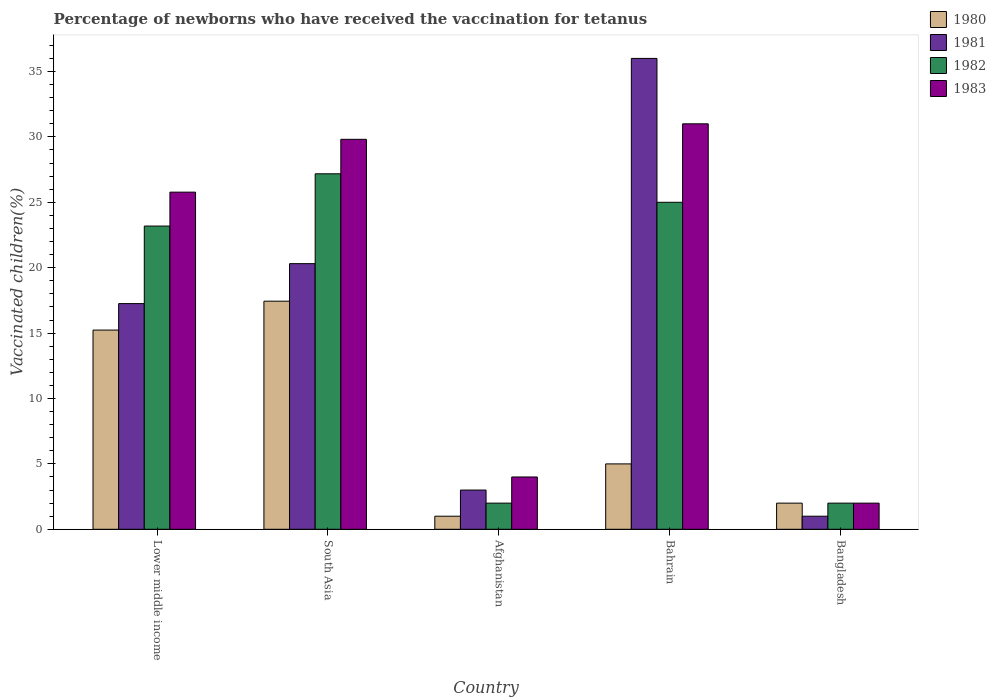Are the number of bars per tick equal to the number of legend labels?
Your answer should be very brief. Yes. What is the label of the 1st group of bars from the left?
Your answer should be very brief. Lower middle income. In how many cases, is the number of bars for a given country not equal to the number of legend labels?
Provide a short and direct response. 0. What is the percentage of vaccinated children in 1982 in Bangladesh?
Your answer should be compact. 2. Across all countries, what is the minimum percentage of vaccinated children in 1981?
Provide a succinct answer. 1. In which country was the percentage of vaccinated children in 1982 maximum?
Give a very brief answer. South Asia. What is the total percentage of vaccinated children in 1981 in the graph?
Offer a terse response. 77.56. What is the difference between the percentage of vaccinated children in 1982 in South Asia and the percentage of vaccinated children in 1981 in Bangladesh?
Your answer should be very brief. 26.18. What is the average percentage of vaccinated children in 1981 per country?
Offer a very short reply. 15.51. What is the difference between the percentage of vaccinated children of/in 1982 and percentage of vaccinated children of/in 1983 in Lower middle income?
Give a very brief answer. -2.59. In how many countries, is the percentage of vaccinated children in 1982 greater than 23 %?
Give a very brief answer. 3. What is the ratio of the percentage of vaccinated children in 1983 in Afghanistan to that in South Asia?
Provide a short and direct response. 0.13. Is the difference between the percentage of vaccinated children in 1982 in Bahrain and South Asia greater than the difference between the percentage of vaccinated children in 1983 in Bahrain and South Asia?
Ensure brevity in your answer.  No. What is the difference between the highest and the second highest percentage of vaccinated children in 1982?
Your response must be concise. -2.18. What is the difference between the highest and the lowest percentage of vaccinated children in 1980?
Keep it short and to the point. 16.44. In how many countries, is the percentage of vaccinated children in 1983 greater than the average percentage of vaccinated children in 1983 taken over all countries?
Provide a succinct answer. 3. How many bars are there?
Your response must be concise. 20. Are all the bars in the graph horizontal?
Make the answer very short. No. How many countries are there in the graph?
Offer a terse response. 5. What is the difference between two consecutive major ticks on the Y-axis?
Your answer should be very brief. 5. Does the graph contain grids?
Offer a terse response. No. How many legend labels are there?
Offer a very short reply. 4. How are the legend labels stacked?
Your answer should be very brief. Vertical. What is the title of the graph?
Your answer should be very brief. Percentage of newborns who have received the vaccination for tetanus. What is the label or title of the X-axis?
Offer a very short reply. Country. What is the label or title of the Y-axis?
Provide a short and direct response. Vaccinated children(%). What is the Vaccinated children(%) of 1980 in Lower middle income?
Provide a short and direct response. 15.23. What is the Vaccinated children(%) of 1981 in Lower middle income?
Offer a very short reply. 17.25. What is the Vaccinated children(%) of 1982 in Lower middle income?
Your response must be concise. 23.18. What is the Vaccinated children(%) in 1983 in Lower middle income?
Make the answer very short. 25.78. What is the Vaccinated children(%) in 1980 in South Asia?
Provide a succinct answer. 17.44. What is the Vaccinated children(%) of 1981 in South Asia?
Make the answer very short. 20.31. What is the Vaccinated children(%) in 1982 in South Asia?
Give a very brief answer. 27.18. What is the Vaccinated children(%) in 1983 in South Asia?
Offer a terse response. 29.81. What is the Vaccinated children(%) of 1980 in Afghanistan?
Make the answer very short. 1. What is the Vaccinated children(%) in 1982 in Afghanistan?
Your answer should be very brief. 2. What is the Vaccinated children(%) in 1982 in Bahrain?
Your answer should be compact. 25. What is the Vaccinated children(%) of 1983 in Bahrain?
Make the answer very short. 31. What is the Vaccinated children(%) in 1981 in Bangladesh?
Offer a very short reply. 1. What is the Vaccinated children(%) of 1982 in Bangladesh?
Offer a terse response. 2. Across all countries, what is the maximum Vaccinated children(%) of 1980?
Give a very brief answer. 17.44. Across all countries, what is the maximum Vaccinated children(%) of 1981?
Keep it short and to the point. 36. Across all countries, what is the maximum Vaccinated children(%) of 1982?
Your answer should be compact. 27.18. Across all countries, what is the maximum Vaccinated children(%) in 1983?
Make the answer very short. 31. Across all countries, what is the minimum Vaccinated children(%) of 1981?
Offer a terse response. 1. Across all countries, what is the minimum Vaccinated children(%) of 1983?
Your response must be concise. 2. What is the total Vaccinated children(%) of 1980 in the graph?
Keep it short and to the point. 40.67. What is the total Vaccinated children(%) in 1981 in the graph?
Offer a very short reply. 77.56. What is the total Vaccinated children(%) in 1982 in the graph?
Give a very brief answer. 79.36. What is the total Vaccinated children(%) in 1983 in the graph?
Give a very brief answer. 92.59. What is the difference between the Vaccinated children(%) in 1980 in Lower middle income and that in South Asia?
Offer a very short reply. -2.21. What is the difference between the Vaccinated children(%) in 1981 in Lower middle income and that in South Asia?
Your response must be concise. -3.05. What is the difference between the Vaccinated children(%) of 1982 in Lower middle income and that in South Asia?
Offer a terse response. -3.99. What is the difference between the Vaccinated children(%) of 1983 in Lower middle income and that in South Asia?
Ensure brevity in your answer.  -4.04. What is the difference between the Vaccinated children(%) in 1980 in Lower middle income and that in Afghanistan?
Make the answer very short. 14.23. What is the difference between the Vaccinated children(%) of 1981 in Lower middle income and that in Afghanistan?
Give a very brief answer. 14.25. What is the difference between the Vaccinated children(%) of 1982 in Lower middle income and that in Afghanistan?
Offer a terse response. 21.18. What is the difference between the Vaccinated children(%) of 1983 in Lower middle income and that in Afghanistan?
Keep it short and to the point. 21.78. What is the difference between the Vaccinated children(%) in 1980 in Lower middle income and that in Bahrain?
Your answer should be very brief. 10.23. What is the difference between the Vaccinated children(%) of 1981 in Lower middle income and that in Bahrain?
Offer a terse response. -18.75. What is the difference between the Vaccinated children(%) of 1982 in Lower middle income and that in Bahrain?
Ensure brevity in your answer.  -1.82. What is the difference between the Vaccinated children(%) of 1983 in Lower middle income and that in Bahrain?
Your answer should be compact. -5.22. What is the difference between the Vaccinated children(%) in 1980 in Lower middle income and that in Bangladesh?
Ensure brevity in your answer.  13.23. What is the difference between the Vaccinated children(%) in 1981 in Lower middle income and that in Bangladesh?
Your response must be concise. 16.25. What is the difference between the Vaccinated children(%) in 1982 in Lower middle income and that in Bangladesh?
Provide a short and direct response. 21.18. What is the difference between the Vaccinated children(%) of 1983 in Lower middle income and that in Bangladesh?
Give a very brief answer. 23.78. What is the difference between the Vaccinated children(%) of 1980 in South Asia and that in Afghanistan?
Keep it short and to the point. 16.44. What is the difference between the Vaccinated children(%) of 1981 in South Asia and that in Afghanistan?
Offer a terse response. 17.31. What is the difference between the Vaccinated children(%) of 1982 in South Asia and that in Afghanistan?
Your response must be concise. 25.18. What is the difference between the Vaccinated children(%) in 1983 in South Asia and that in Afghanistan?
Your answer should be very brief. 25.81. What is the difference between the Vaccinated children(%) in 1980 in South Asia and that in Bahrain?
Your answer should be compact. 12.44. What is the difference between the Vaccinated children(%) in 1981 in South Asia and that in Bahrain?
Provide a succinct answer. -15.69. What is the difference between the Vaccinated children(%) of 1982 in South Asia and that in Bahrain?
Give a very brief answer. 2.18. What is the difference between the Vaccinated children(%) of 1983 in South Asia and that in Bahrain?
Make the answer very short. -1.19. What is the difference between the Vaccinated children(%) in 1980 in South Asia and that in Bangladesh?
Ensure brevity in your answer.  15.44. What is the difference between the Vaccinated children(%) in 1981 in South Asia and that in Bangladesh?
Provide a succinct answer. 19.31. What is the difference between the Vaccinated children(%) in 1982 in South Asia and that in Bangladesh?
Give a very brief answer. 25.18. What is the difference between the Vaccinated children(%) of 1983 in South Asia and that in Bangladesh?
Your response must be concise. 27.81. What is the difference between the Vaccinated children(%) of 1981 in Afghanistan and that in Bahrain?
Give a very brief answer. -33. What is the difference between the Vaccinated children(%) in 1982 in Afghanistan and that in Bahrain?
Give a very brief answer. -23. What is the difference between the Vaccinated children(%) of 1983 in Afghanistan and that in Bahrain?
Give a very brief answer. -27. What is the difference between the Vaccinated children(%) of 1981 in Afghanistan and that in Bangladesh?
Provide a short and direct response. 2. What is the difference between the Vaccinated children(%) of 1983 in Afghanistan and that in Bangladesh?
Your answer should be compact. 2. What is the difference between the Vaccinated children(%) of 1980 in Bahrain and that in Bangladesh?
Offer a terse response. 3. What is the difference between the Vaccinated children(%) in 1983 in Bahrain and that in Bangladesh?
Give a very brief answer. 29. What is the difference between the Vaccinated children(%) in 1980 in Lower middle income and the Vaccinated children(%) in 1981 in South Asia?
Give a very brief answer. -5.08. What is the difference between the Vaccinated children(%) of 1980 in Lower middle income and the Vaccinated children(%) of 1982 in South Asia?
Offer a very short reply. -11.95. What is the difference between the Vaccinated children(%) in 1980 in Lower middle income and the Vaccinated children(%) in 1983 in South Asia?
Provide a succinct answer. -14.58. What is the difference between the Vaccinated children(%) in 1981 in Lower middle income and the Vaccinated children(%) in 1982 in South Asia?
Offer a terse response. -9.92. What is the difference between the Vaccinated children(%) of 1981 in Lower middle income and the Vaccinated children(%) of 1983 in South Asia?
Give a very brief answer. -12.56. What is the difference between the Vaccinated children(%) of 1982 in Lower middle income and the Vaccinated children(%) of 1983 in South Asia?
Provide a short and direct response. -6.63. What is the difference between the Vaccinated children(%) in 1980 in Lower middle income and the Vaccinated children(%) in 1981 in Afghanistan?
Provide a succinct answer. 12.23. What is the difference between the Vaccinated children(%) of 1980 in Lower middle income and the Vaccinated children(%) of 1982 in Afghanistan?
Your answer should be very brief. 13.23. What is the difference between the Vaccinated children(%) in 1980 in Lower middle income and the Vaccinated children(%) in 1983 in Afghanistan?
Keep it short and to the point. 11.23. What is the difference between the Vaccinated children(%) of 1981 in Lower middle income and the Vaccinated children(%) of 1982 in Afghanistan?
Your response must be concise. 15.25. What is the difference between the Vaccinated children(%) in 1981 in Lower middle income and the Vaccinated children(%) in 1983 in Afghanistan?
Keep it short and to the point. 13.25. What is the difference between the Vaccinated children(%) in 1982 in Lower middle income and the Vaccinated children(%) in 1983 in Afghanistan?
Keep it short and to the point. 19.18. What is the difference between the Vaccinated children(%) in 1980 in Lower middle income and the Vaccinated children(%) in 1981 in Bahrain?
Your answer should be very brief. -20.77. What is the difference between the Vaccinated children(%) in 1980 in Lower middle income and the Vaccinated children(%) in 1982 in Bahrain?
Offer a very short reply. -9.77. What is the difference between the Vaccinated children(%) of 1980 in Lower middle income and the Vaccinated children(%) of 1983 in Bahrain?
Ensure brevity in your answer.  -15.77. What is the difference between the Vaccinated children(%) of 1981 in Lower middle income and the Vaccinated children(%) of 1982 in Bahrain?
Your response must be concise. -7.75. What is the difference between the Vaccinated children(%) of 1981 in Lower middle income and the Vaccinated children(%) of 1983 in Bahrain?
Provide a short and direct response. -13.75. What is the difference between the Vaccinated children(%) of 1982 in Lower middle income and the Vaccinated children(%) of 1983 in Bahrain?
Provide a short and direct response. -7.82. What is the difference between the Vaccinated children(%) in 1980 in Lower middle income and the Vaccinated children(%) in 1981 in Bangladesh?
Your answer should be very brief. 14.23. What is the difference between the Vaccinated children(%) in 1980 in Lower middle income and the Vaccinated children(%) in 1982 in Bangladesh?
Offer a very short reply. 13.23. What is the difference between the Vaccinated children(%) of 1980 in Lower middle income and the Vaccinated children(%) of 1983 in Bangladesh?
Your answer should be very brief. 13.23. What is the difference between the Vaccinated children(%) in 1981 in Lower middle income and the Vaccinated children(%) in 1982 in Bangladesh?
Provide a short and direct response. 15.25. What is the difference between the Vaccinated children(%) of 1981 in Lower middle income and the Vaccinated children(%) of 1983 in Bangladesh?
Your answer should be compact. 15.25. What is the difference between the Vaccinated children(%) of 1982 in Lower middle income and the Vaccinated children(%) of 1983 in Bangladesh?
Your answer should be compact. 21.18. What is the difference between the Vaccinated children(%) in 1980 in South Asia and the Vaccinated children(%) in 1981 in Afghanistan?
Keep it short and to the point. 14.44. What is the difference between the Vaccinated children(%) of 1980 in South Asia and the Vaccinated children(%) of 1982 in Afghanistan?
Offer a terse response. 15.44. What is the difference between the Vaccinated children(%) of 1980 in South Asia and the Vaccinated children(%) of 1983 in Afghanistan?
Give a very brief answer. 13.44. What is the difference between the Vaccinated children(%) of 1981 in South Asia and the Vaccinated children(%) of 1982 in Afghanistan?
Your response must be concise. 18.31. What is the difference between the Vaccinated children(%) in 1981 in South Asia and the Vaccinated children(%) in 1983 in Afghanistan?
Keep it short and to the point. 16.31. What is the difference between the Vaccinated children(%) of 1982 in South Asia and the Vaccinated children(%) of 1983 in Afghanistan?
Provide a succinct answer. 23.18. What is the difference between the Vaccinated children(%) of 1980 in South Asia and the Vaccinated children(%) of 1981 in Bahrain?
Offer a terse response. -18.56. What is the difference between the Vaccinated children(%) of 1980 in South Asia and the Vaccinated children(%) of 1982 in Bahrain?
Offer a very short reply. -7.56. What is the difference between the Vaccinated children(%) of 1980 in South Asia and the Vaccinated children(%) of 1983 in Bahrain?
Your response must be concise. -13.56. What is the difference between the Vaccinated children(%) in 1981 in South Asia and the Vaccinated children(%) in 1982 in Bahrain?
Offer a terse response. -4.69. What is the difference between the Vaccinated children(%) in 1981 in South Asia and the Vaccinated children(%) in 1983 in Bahrain?
Your answer should be compact. -10.69. What is the difference between the Vaccinated children(%) of 1982 in South Asia and the Vaccinated children(%) of 1983 in Bahrain?
Your answer should be very brief. -3.82. What is the difference between the Vaccinated children(%) in 1980 in South Asia and the Vaccinated children(%) in 1981 in Bangladesh?
Give a very brief answer. 16.44. What is the difference between the Vaccinated children(%) in 1980 in South Asia and the Vaccinated children(%) in 1982 in Bangladesh?
Give a very brief answer. 15.44. What is the difference between the Vaccinated children(%) of 1980 in South Asia and the Vaccinated children(%) of 1983 in Bangladesh?
Your response must be concise. 15.44. What is the difference between the Vaccinated children(%) in 1981 in South Asia and the Vaccinated children(%) in 1982 in Bangladesh?
Give a very brief answer. 18.31. What is the difference between the Vaccinated children(%) of 1981 in South Asia and the Vaccinated children(%) of 1983 in Bangladesh?
Make the answer very short. 18.31. What is the difference between the Vaccinated children(%) in 1982 in South Asia and the Vaccinated children(%) in 1983 in Bangladesh?
Give a very brief answer. 25.18. What is the difference between the Vaccinated children(%) of 1980 in Afghanistan and the Vaccinated children(%) of 1981 in Bahrain?
Provide a succinct answer. -35. What is the difference between the Vaccinated children(%) in 1980 in Afghanistan and the Vaccinated children(%) in 1983 in Bahrain?
Your answer should be compact. -30. What is the difference between the Vaccinated children(%) of 1981 in Afghanistan and the Vaccinated children(%) of 1983 in Bahrain?
Provide a short and direct response. -28. What is the difference between the Vaccinated children(%) of 1980 in Afghanistan and the Vaccinated children(%) of 1981 in Bangladesh?
Offer a very short reply. 0. What is the difference between the Vaccinated children(%) of 1980 in Afghanistan and the Vaccinated children(%) of 1983 in Bangladesh?
Provide a short and direct response. -1. What is the difference between the Vaccinated children(%) in 1981 in Afghanistan and the Vaccinated children(%) in 1982 in Bangladesh?
Provide a succinct answer. 1. What is the difference between the Vaccinated children(%) of 1982 in Afghanistan and the Vaccinated children(%) of 1983 in Bangladesh?
Keep it short and to the point. 0. What is the difference between the Vaccinated children(%) in 1980 in Bahrain and the Vaccinated children(%) in 1981 in Bangladesh?
Your response must be concise. 4. What is the difference between the Vaccinated children(%) in 1980 in Bahrain and the Vaccinated children(%) in 1982 in Bangladesh?
Give a very brief answer. 3. What is the difference between the Vaccinated children(%) in 1980 in Bahrain and the Vaccinated children(%) in 1983 in Bangladesh?
Provide a short and direct response. 3. What is the difference between the Vaccinated children(%) of 1981 in Bahrain and the Vaccinated children(%) of 1982 in Bangladesh?
Give a very brief answer. 34. What is the difference between the Vaccinated children(%) in 1981 in Bahrain and the Vaccinated children(%) in 1983 in Bangladesh?
Offer a terse response. 34. What is the average Vaccinated children(%) in 1980 per country?
Provide a short and direct response. 8.13. What is the average Vaccinated children(%) of 1981 per country?
Your answer should be very brief. 15.51. What is the average Vaccinated children(%) of 1982 per country?
Provide a short and direct response. 15.87. What is the average Vaccinated children(%) in 1983 per country?
Your response must be concise. 18.52. What is the difference between the Vaccinated children(%) in 1980 and Vaccinated children(%) in 1981 in Lower middle income?
Your answer should be compact. -2.02. What is the difference between the Vaccinated children(%) of 1980 and Vaccinated children(%) of 1982 in Lower middle income?
Offer a terse response. -7.95. What is the difference between the Vaccinated children(%) in 1980 and Vaccinated children(%) in 1983 in Lower middle income?
Your answer should be compact. -10.54. What is the difference between the Vaccinated children(%) in 1981 and Vaccinated children(%) in 1982 in Lower middle income?
Provide a short and direct response. -5.93. What is the difference between the Vaccinated children(%) in 1981 and Vaccinated children(%) in 1983 in Lower middle income?
Make the answer very short. -8.52. What is the difference between the Vaccinated children(%) in 1982 and Vaccinated children(%) in 1983 in Lower middle income?
Make the answer very short. -2.59. What is the difference between the Vaccinated children(%) in 1980 and Vaccinated children(%) in 1981 in South Asia?
Provide a short and direct response. -2.87. What is the difference between the Vaccinated children(%) of 1980 and Vaccinated children(%) of 1982 in South Asia?
Make the answer very short. -9.74. What is the difference between the Vaccinated children(%) in 1980 and Vaccinated children(%) in 1983 in South Asia?
Ensure brevity in your answer.  -12.37. What is the difference between the Vaccinated children(%) of 1981 and Vaccinated children(%) of 1982 in South Asia?
Offer a very short reply. -6.87. What is the difference between the Vaccinated children(%) in 1981 and Vaccinated children(%) in 1983 in South Asia?
Keep it short and to the point. -9.51. What is the difference between the Vaccinated children(%) of 1982 and Vaccinated children(%) of 1983 in South Asia?
Offer a very short reply. -2.64. What is the difference between the Vaccinated children(%) of 1980 and Vaccinated children(%) of 1981 in Afghanistan?
Your answer should be very brief. -2. What is the difference between the Vaccinated children(%) of 1980 and Vaccinated children(%) of 1982 in Afghanistan?
Your response must be concise. -1. What is the difference between the Vaccinated children(%) in 1980 and Vaccinated children(%) in 1983 in Afghanistan?
Your response must be concise. -3. What is the difference between the Vaccinated children(%) of 1982 and Vaccinated children(%) of 1983 in Afghanistan?
Provide a short and direct response. -2. What is the difference between the Vaccinated children(%) of 1980 and Vaccinated children(%) of 1981 in Bahrain?
Provide a succinct answer. -31. What is the difference between the Vaccinated children(%) of 1980 and Vaccinated children(%) of 1983 in Bahrain?
Provide a succinct answer. -26. What is the difference between the Vaccinated children(%) in 1981 and Vaccinated children(%) in 1983 in Bahrain?
Ensure brevity in your answer.  5. What is the difference between the Vaccinated children(%) in 1980 and Vaccinated children(%) in 1981 in Bangladesh?
Offer a terse response. 1. What is the difference between the Vaccinated children(%) in 1981 and Vaccinated children(%) in 1982 in Bangladesh?
Provide a succinct answer. -1. What is the ratio of the Vaccinated children(%) in 1980 in Lower middle income to that in South Asia?
Provide a short and direct response. 0.87. What is the ratio of the Vaccinated children(%) in 1981 in Lower middle income to that in South Asia?
Your answer should be compact. 0.85. What is the ratio of the Vaccinated children(%) in 1982 in Lower middle income to that in South Asia?
Keep it short and to the point. 0.85. What is the ratio of the Vaccinated children(%) in 1983 in Lower middle income to that in South Asia?
Offer a very short reply. 0.86. What is the ratio of the Vaccinated children(%) in 1980 in Lower middle income to that in Afghanistan?
Your answer should be compact. 15.23. What is the ratio of the Vaccinated children(%) in 1981 in Lower middle income to that in Afghanistan?
Ensure brevity in your answer.  5.75. What is the ratio of the Vaccinated children(%) of 1982 in Lower middle income to that in Afghanistan?
Provide a succinct answer. 11.59. What is the ratio of the Vaccinated children(%) in 1983 in Lower middle income to that in Afghanistan?
Ensure brevity in your answer.  6.44. What is the ratio of the Vaccinated children(%) of 1980 in Lower middle income to that in Bahrain?
Make the answer very short. 3.05. What is the ratio of the Vaccinated children(%) in 1981 in Lower middle income to that in Bahrain?
Provide a succinct answer. 0.48. What is the ratio of the Vaccinated children(%) of 1982 in Lower middle income to that in Bahrain?
Your response must be concise. 0.93. What is the ratio of the Vaccinated children(%) of 1983 in Lower middle income to that in Bahrain?
Keep it short and to the point. 0.83. What is the ratio of the Vaccinated children(%) of 1980 in Lower middle income to that in Bangladesh?
Provide a short and direct response. 7.62. What is the ratio of the Vaccinated children(%) in 1981 in Lower middle income to that in Bangladesh?
Offer a very short reply. 17.25. What is the ratio of the Vaccinated children(%) of 1982 in Lower middle income to that in Bangladesh?
Give a very brief answer. 11.59. What is the ratio of the Vaccinated children(%) in 1983 in Lower middle income to that in Bangladesh?
Offer a terse response. 12.89. What is the ratio of the Vaccinated children(%) in 1980 in South Asia to that in Afghanistan?
Give a very brief answer. 17.44. What is the ratio of the Vaccinated children(%) of 1981 in South Asia to that in Afghanistan?
Ensure brevity in your answer.  6.77. What is the ratio of the Vaccinated children(%) in 1982 in South Asia to that in Afghanistan?
Your answer should be compact. 13.59. What is the ratio of the Vaccinated children(%) of 1983 in South Asia to that in Afghanistan?
Give a very brief answer. 7.45. What is the ratio of the Vaccinated children(%) in 1980 in South Asia to that in Bahrain?
Your answer should be compact. 3.49. What is the ratio of the Vaccinated children(%) in 1981 in South Asia to that in Bahrain?
Ensure brevity in your answer.  0.56. What is the ratio of the Vaccinated children(%) of 1982 in South Asia to that in Bahrain?
Ensure brevity in your answer.  1.09. What is the ratio of the Vaccinated children(%) in 1983 in South Asia to that in Bahrain?
Ensure brevity in your answer.  0.96. What is the ratio of the Vaccinated children(%) of 1980 in South Asia to that in Bangladesh?
Provide a succinct answer. 8.72. What is the ratio of the Vaccinated children(%) in 1981 in South Asia to that in Bangladesh?
Give a very brief answer. 20.31. What is the ratio of the Vaccinated children(%) in 1982 in South Asia to that in Bangladesh?
Offer a very short reply. 13.59. What is the ratio of the Vaccinated children(%) of 1983 in South Asia to that in Bangladesh?
Make the answer very short. 14.91. What is the ratio of the Vaccinated children(%) of 1981 in Afghanistan to that in Bahrain?
Provide a succinct answer. 0.08. What is the ratio of the Vaccinated children(%) of 1983 in Afghanistan to that in Bahrain?
Give a very brief answer. 0.13. What is the ratio of the Vaccinated children(%) in 1982 in Afghanistan to that in Bangladesh?
Provide a succinct answer. 1. What is the ratio of the Vaccinated children(%) of 1983 in Afghanistan to that in Bangladesh?
Your answer should be very brief. 2. What is the ratio of the Vaccinated children(%) in 1980 in Bahrain to that in Bangladesh?
Make the answer very short. 2.5. What is the ratio of the Vaccinated children(%) of 1981 in Bahrain to that in Bangladesh?
Make the answer very short. 36. What is the ratio of the Vaccinated children(%) of 1983 in Bahrain to that in Bangladesh?
Your answer should be compact. 15.5. What is the difference between the highest and the second highest Vaccinated children(%) in 1980?
Offer a terse response. 2.21. What is the difference between the highest and the second highest Vaccinated children(%) of 1981?
Your answer should be compact. 15.69. What is the difference between the highest and the second highest Vaccinated children(%) of 1982?
Make the answer very short. 2.18. What is the difference between the highest and the second highest Vaccinated children(%) of 1983?
Keep it short and to the point. 1.19. What is the difference between the highest and the lowest Vaccinated children(%) in 1980?
Offer a very short reply. 16.44. What is the difference between the highest and the lowest Vaccinated children(%) of 1981?
Offer a terse response. 35. What is the difference between the highest and the lowest Vaccinated children(%) in 1982?
Make the answer very short. 25.18. 